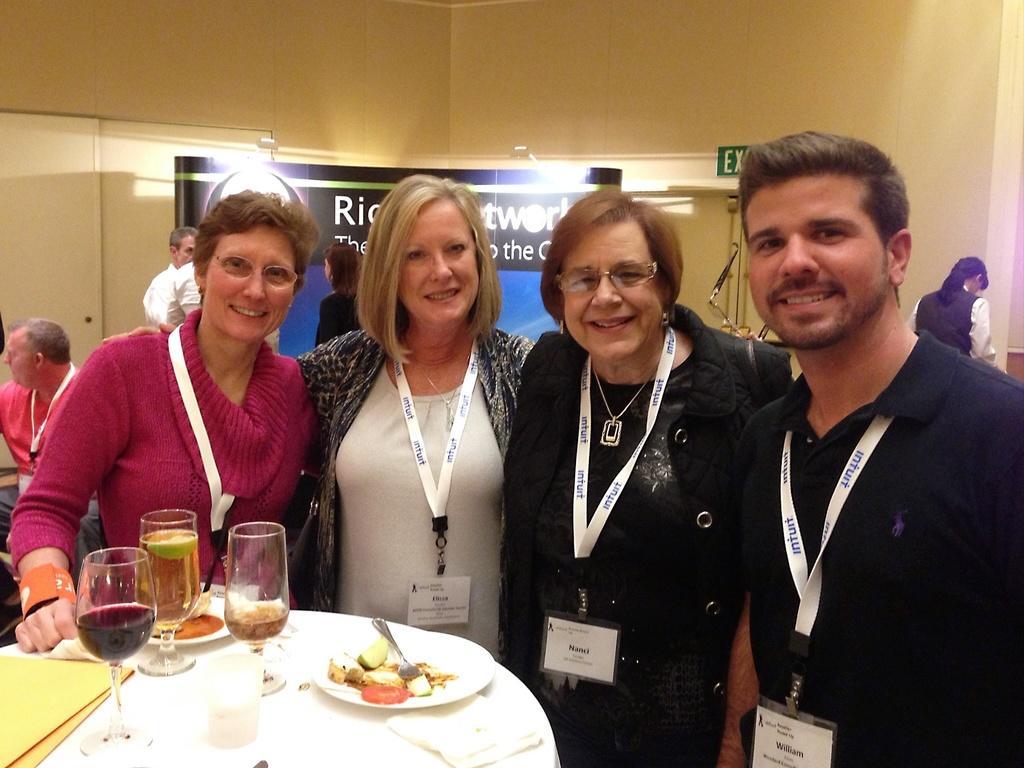How would you summarize this image in a sentence or two? In this image, there are four persons wearing id cards and standing in front of the table. This table contains some glasses and food. There is a banner in the middle of the image. 